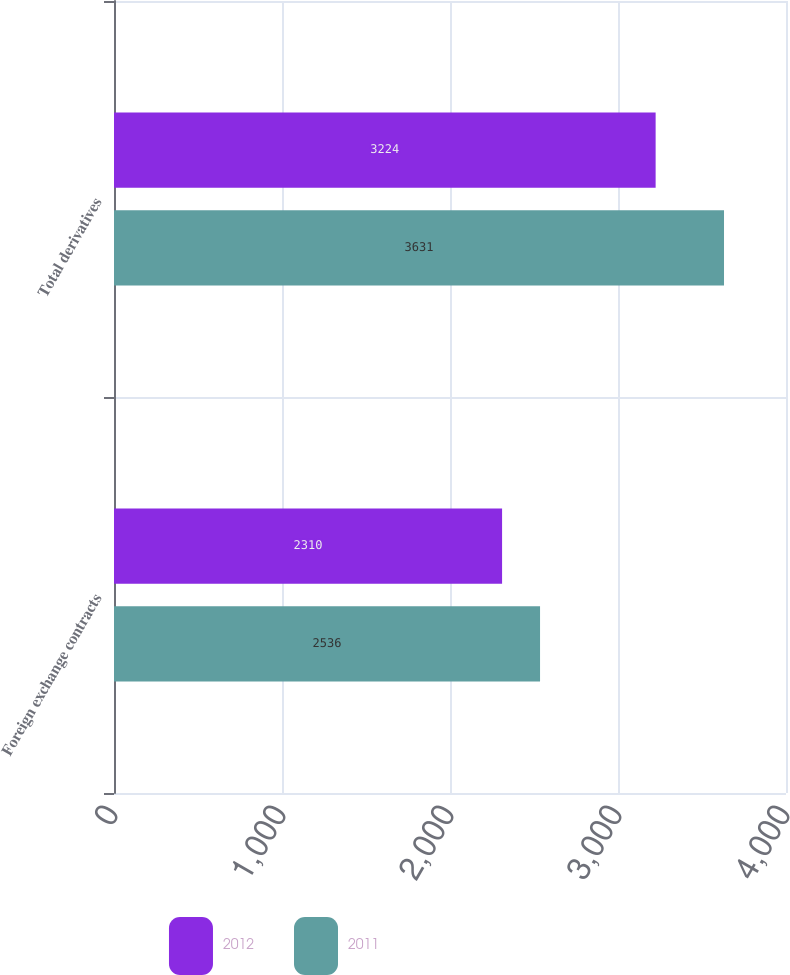Convert chart. <chart><loc_0><loc_0><loc_500><loc_500><stacked_bar_chart><ecel><fcel>Foreign exchange contracts<fcel>Total derivatives<nl><fcel>2012<fcel>2310<fcel>3224<nl><fcel>2011<fcel>2536<fcel>3631<nl></chart> 